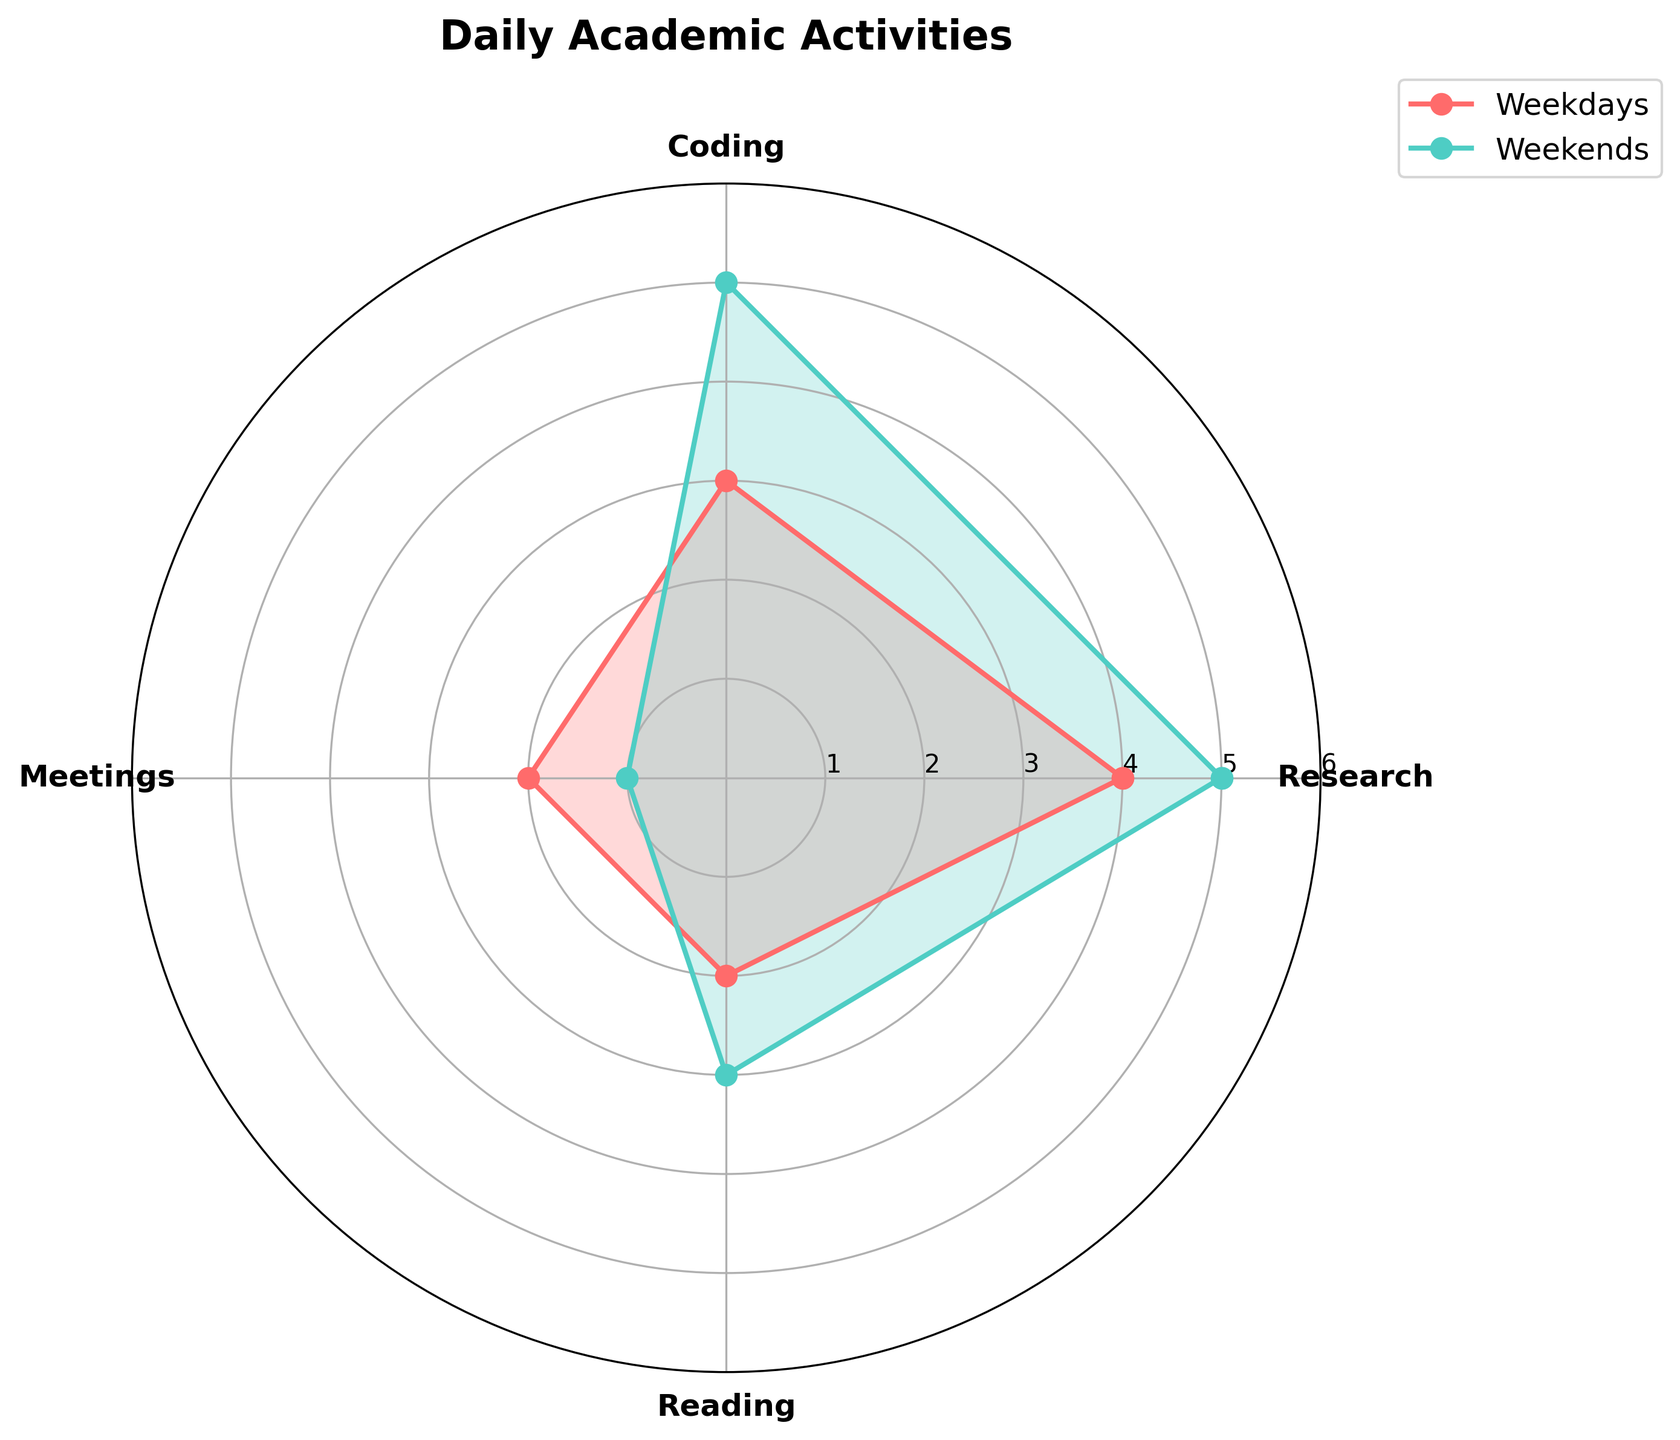What's the title of the chart? The title can be read directly from the chart above the plot area.
Answer: Daily Academic Activities How many activities are tracked in the chart? Count the number of unique labels on the x-axis in the radar chart.
Answer: 4 Which group spends more time coding per day? Look at the Coding data points for both weekdays and weekends and compare their heights.
Answer: Weekends By how many hours does the weekend research time exceed the weekday research time? Locate the Research data points for both weekdays and weekends, then subtract the weekday value from the weekend value (5 - 4).
Answer: 1 hour Which group spends the least amount of time in meetings? Identify the data points for Meetings for both groups and determine the lower value.
Answer: Weekends What is the total amount of time spent on activities for weekdays? Add all the values for weekdays: Research (4) + Coding (3) + Meetings (2) + Reading (2).
Answer: 11 hours How much more time is allocated for reading on weekends compared to weekdays? Determine the Reading values for both weekdays and weekends, then calculate the difference (3 - 2).
Answer: 1 hour Which activity shows the greatest difference in time allocation between weekends and weekdays? Examine all activities and calculate the difference for each: Research (5-4=1), Coding (5-3=2), Meetings (2-1=1), Reading (3-2=1). The largest difference is for Coding.
Answer: Coding What is the average amount of time spent on coding for both groups? Find the Coding values for both weekdays (3) and weekends (5), then compute the average: (3+5)/2.
Answer: 4 hours On weekends, is there more time spent on meetings or reading? Compare the data points for Meetings and Reading on weekends.
Answer: Reading 